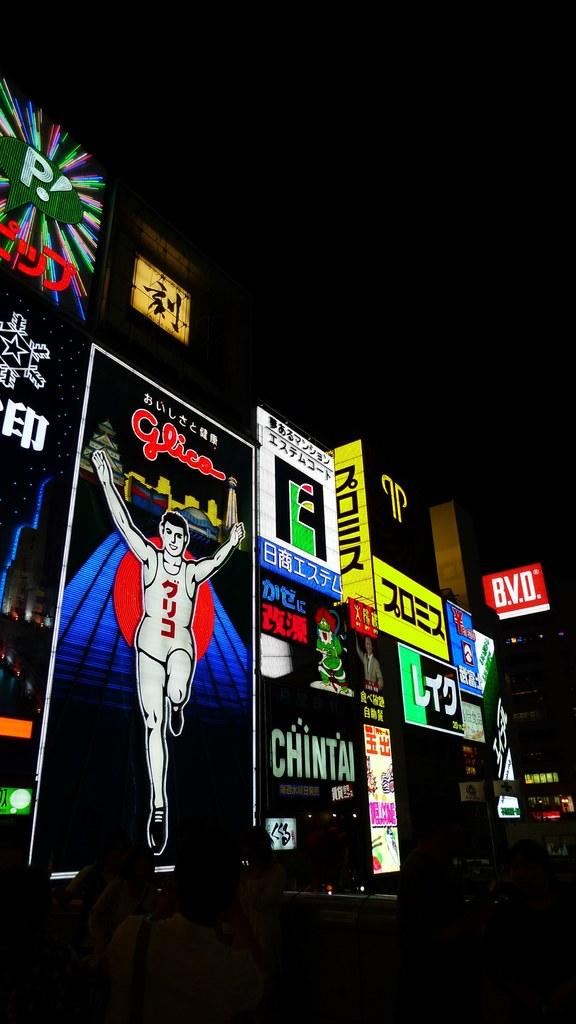<image>
Share a concise interpretation of the image provided. Lit up billboards at night featuring Chintai, B.V.D.,  and Glica. 